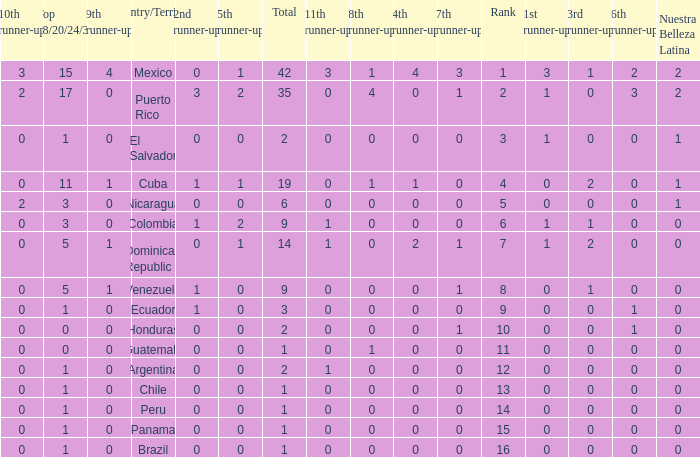What is the 7th runner-up of the country with a 10th runner-up greater than 0, a 9th runner-up greater than 0, and an 8th runner-up greater than 1? None. 